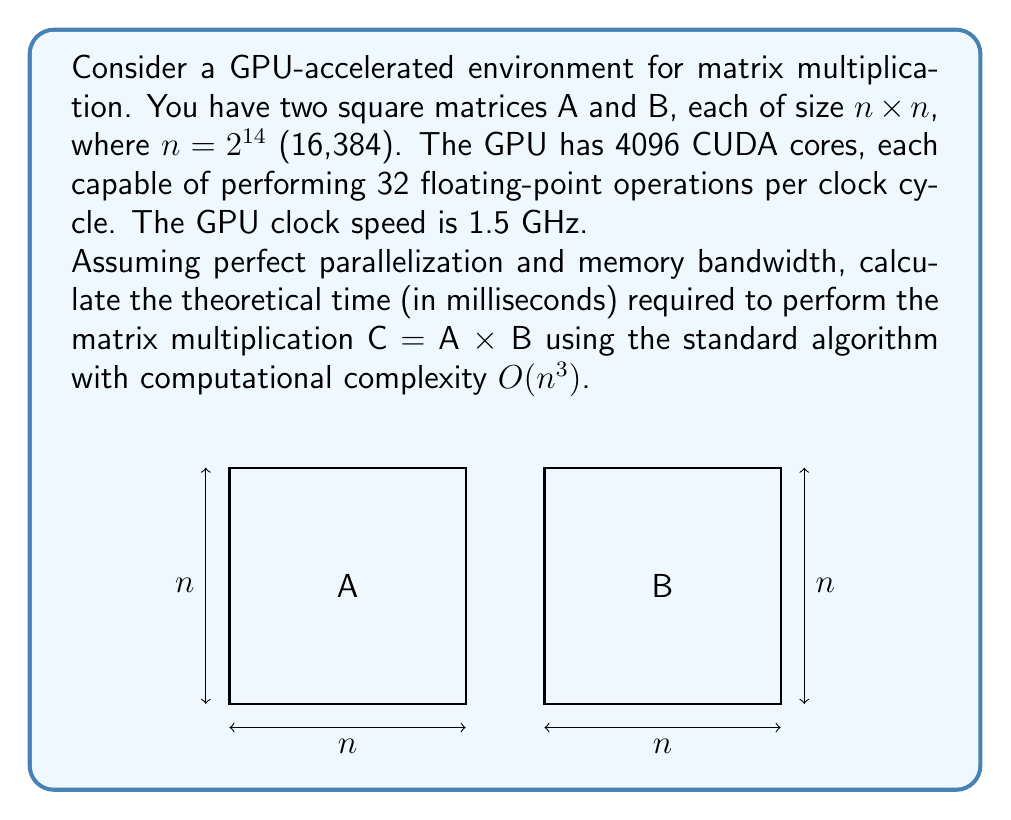Could you help me with this problem? Let's approach this step-by-step:

1) First, let's calculate the total number of floating-point operations required for the matrix multiplication:
   - For an $n \times n$ matrix multiplication, we need $n^3$ multiplications and $(n-1)n^2$ additions.
   - Total operations $= n^3 + (n-1)n^2 \approx 2n^3$ for large $n$.
   - With $n = 2^{14} = 16,384$, we have:
     $$\text{Total operations} \approx 2 \times (2^{14})^3 = 2 \times 2^{42} = 2^{43} \approx 8.80 \times 10^{12}$$

2) Now, let's calculate the GPU's theoretical performance:
   - CUDA cores = 4096
   - Operations per core per cycle = 32
   - Clock speed = 1.5 GHz = $1.5 \times 10^9$ cycles/second
   - Theoretical performance $= 4096 \times 32 \times 1.5 \times 10^9 = 1.97 \times 10^{14}$ operations/second

3) Time required:
   $$\text{Time} = \frac{\text{Total operations}}{\text{Theoretical performance}}$$
   $$= \frac{8.80 \times 10^{12}}{1.97 \times 10^{14}} \approx 0.0447 \text{ seconds}$$

4) Convert to milliseconds:
   $$0.0447 \text{ seconds} \times 1000 = 44.7 \text{ milliseconds}$$

Therefore, the theoretical time required is approximately 44.7 milliseconds.
Answer: 44.7 ms 